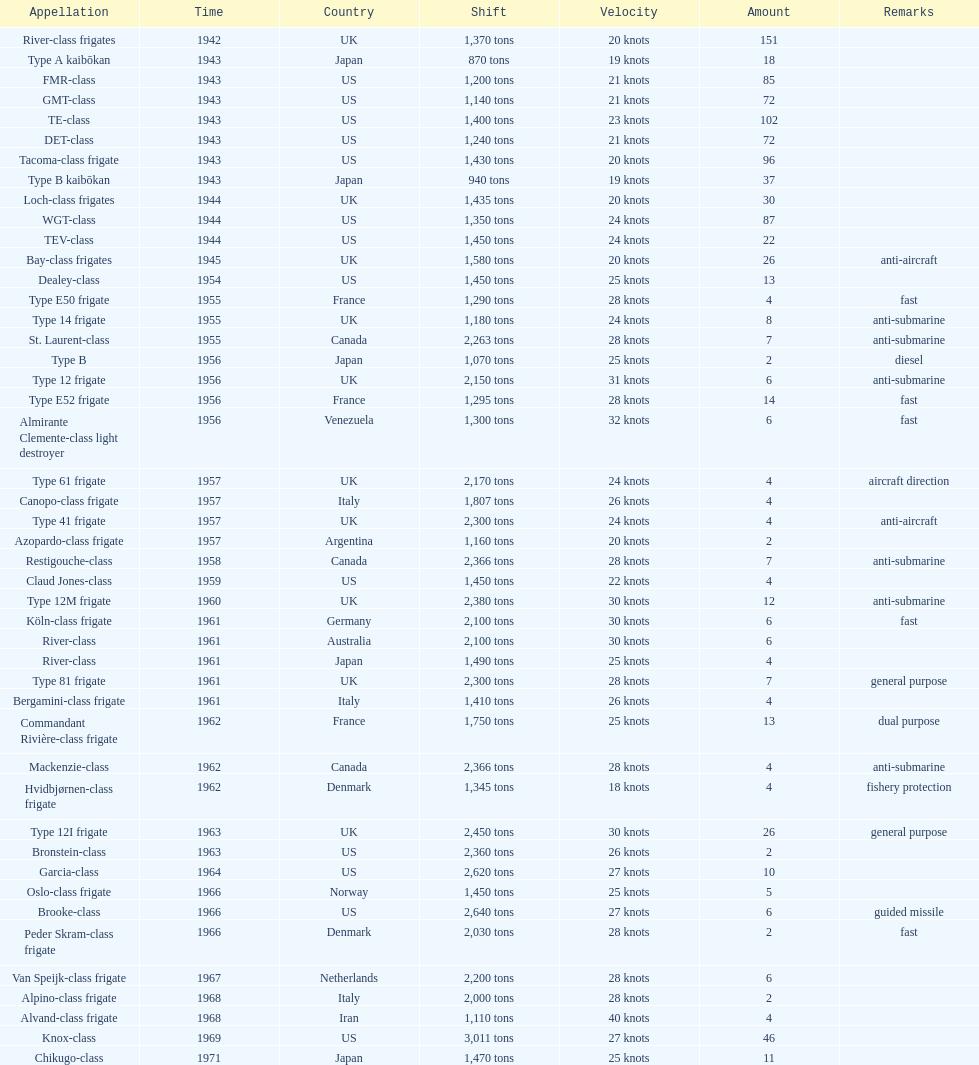In 1968 italy used alpino-class frigate. what was its top speed? 28 knots. 